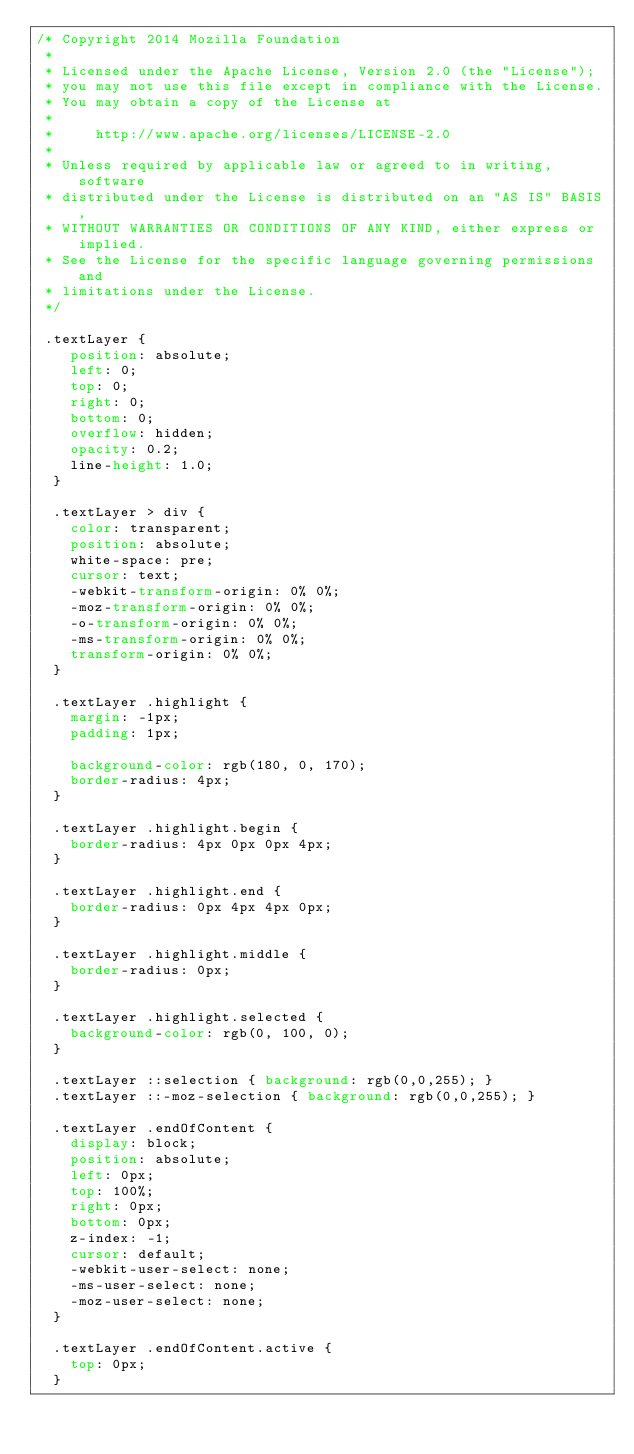Convert code to text. <code><loc_0><loc_0><loc_500><loc_500><_CSS_>/* Copyright 2014 Mozilla Foundation
 *
 * Licensed under the Apache License, Version 2.0 (the "License");
 * you may not use this file except in compliance with the License.
 * You may obtain a copy of the License at
 *
 *     http://www.apache.org/licenses/LICENSE-2.0
 *
 * Unless required by applicable law or agreed to in writing, software
 * distributed under the License is distributed on an "AS IS" BASIS,
 * WITHOUT WARRANTIES OR CONDITIONS OF ANY KIND, either express or implied.
 * See the License for the specific language governing permissions and
 * limitations under the License.
 */

 .textLayer {
    position: absolute;
    left: 0;
    top: 0;
    right: 0;
    bottom: 0;
    overflow: hidden;
    opacity: 0.2;
    line-height: 1.0;
  }
  
  .textLayer > div {
    color: transparent;
    position: absolute;
    white-space: pre;
    cursor: text;
    -webkit-transform-origin: 0% 0%;
    -moz-transform-origin: 0% 0%;
    -o-transform-origin: 0% 0%;
    -ms-transform-origin: 0% 0%;
    transform-origin: 0% 0%;
  }
  
  .textLayer .highlight {
    margin: -1px;
    padding: 1px;
  
    background-color: rgb(180, 0, 170);
    border-radius: 4px;
  }
  
  .textLayer .highlight.begin {
    border-radius: 4px 0px 0px 4px;
  }
  
  .textLayer .highlight.end {
    border-radius: 0px 4px 4px 0px;
  }
  
  .textLayer .highlight.middle {
    border-radius: 0px;
  }
  
  .textLayer .highlight.selected {
    background-color: rgb(0, 100, 0);
  }
  
  .textLayer ::selection { background: rgb(0,0,255); }
  .textLayer ::-moz-selection { background: rgb(0,0,255); }
  
  .textLayer .endOfContent {
    display: block;
    position: absolute;
    left: 0px;
    top: 100%;
    right: 0px;
    bottom: 0px;
    z-index: -1;
    cursor: default;
    -webkit-user-select: none;
    -ms-user-select: none;
    -moz-user-select: none;
  }
  
  .textLayer .endOfContent.active {
    top: 0px;
  }
  
  </code> 